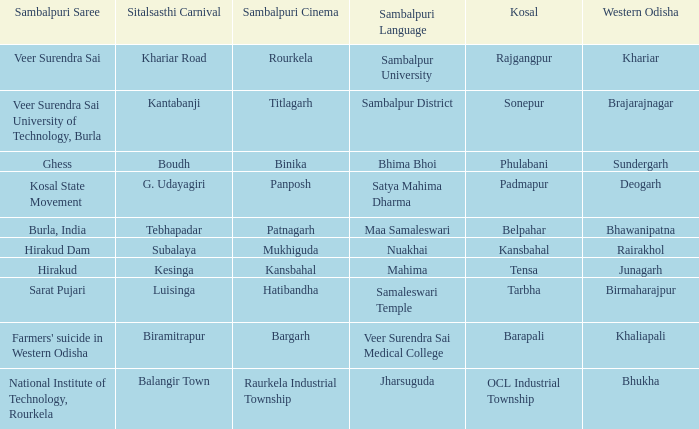What is the sitalsasthi carnival with hirakud as sambalpuri saree? Kesinga. 